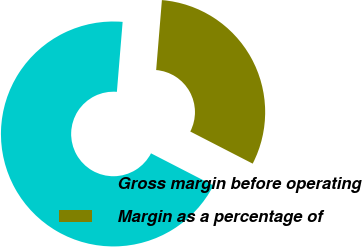Convert chart to OTSL. <chart><loc_0><loc_0><loc_500><loc_500><pie_chart><fcel>Gross margin before operating<fcel>Margin as a percentage of<nl><fcel>68.74%<fcel>31.26%<nl></chart> 